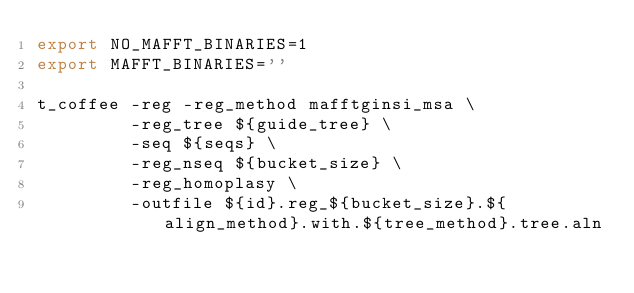<code> <loc_0><loc_0><loc_500><loc_500><_Bash_>export NO_MAFFT_BINARIES=1
export MAFFT_BINARIES=''

t_coffee -reg -reg_method mafftginsi_msa \
         -reg_tree ${guide_tree} \
         -seq ${seqs} \
         -reg_nseq ${bucket_size} \
         -reg_homoplasy \
         -outfile ${id}.reg_${bucket_size}.${align_method}.with.${tree_method}.tree.aln
</code> 